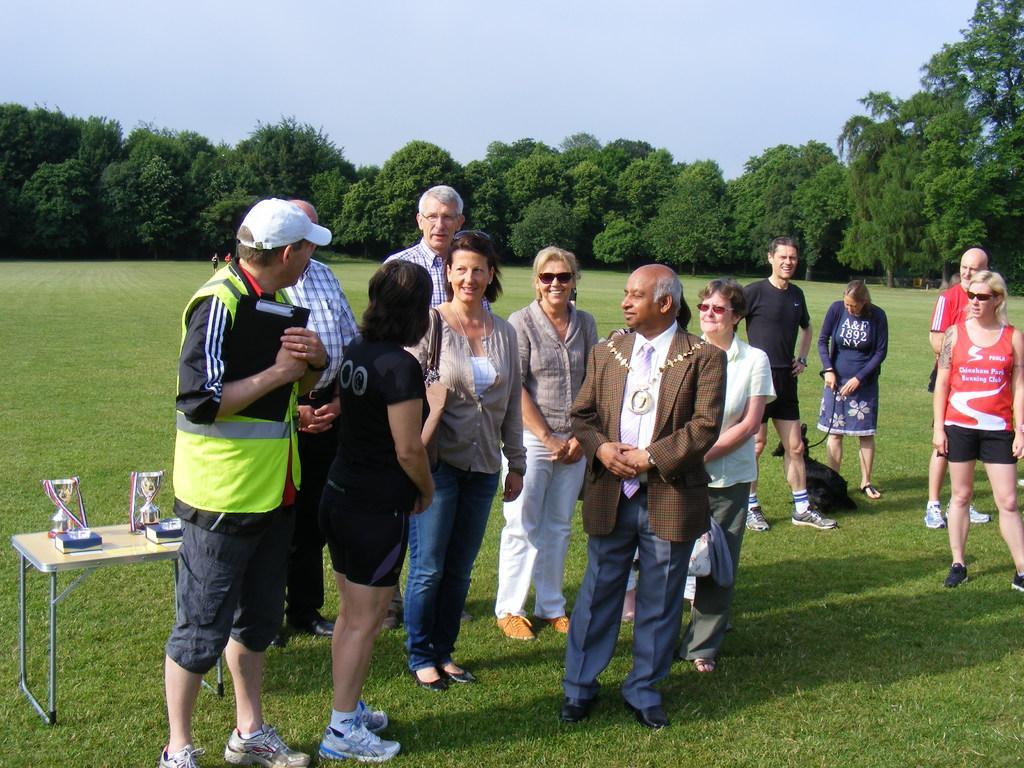Can you describe this image briefly? There is a group of persons standing on a grassy land at the bottom of this image and there are some trees in the background. There is a sky at the top of this image. There are two trophies are kept on a table at the bottom left side of this image. 